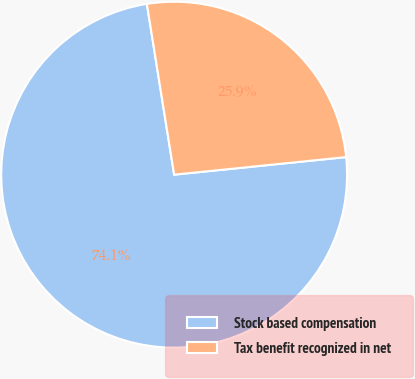Convert chart. <chart><loc_0><loc_0><loc_500><loc_500><pie_chart><fcel>Stock based compensation<fcel>Tax benefit recognized in net<nl><fcel>74.1%<fcel>25.9%<nl></chart> 